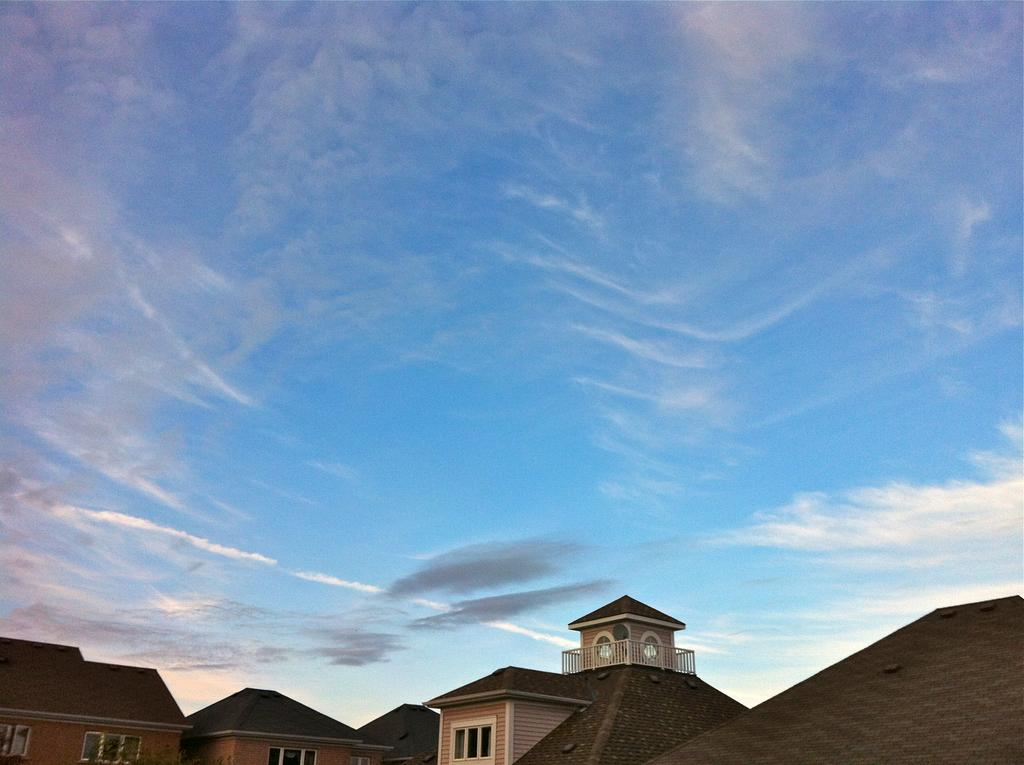What type of structures are located at the bottom of the image? There are buildings in the bottom of the image. What part of the natural environment is visible in the image? The sky is visible at the top of the image. How many birds are flying in the sky in the image? There is no mention of birds in the image, so we cannot determine the number of birds present. 